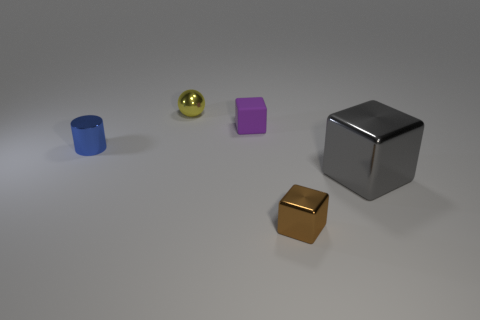Is there any other thing that is the same material as the purple cube?
Make the answer very short. No. There is a gray thing that is the same material as the cylinder; what size is it?
Give a very brief answer. Large. There is a thing behind the purple thing; is there a metal object behind it?
Offer a very short reply. No. What number of other things are the same color as the metallic sphere?
Offer a very short reply. 0. The yellow sphere is what size?
Make the answer very short. Small. Is there a large blue matte cube?
Ensure brevity in your answer.  No. Is the number of blue shiny cylinders that are in front of the cylinder greater than the number of large gray shiny cubes to the left of the brown object?
Keep it short and to the point. No. The thing that is both in front of the yellow shiny sphere and behind the small blue thing is made of what material?
Your response must be concise. Rubber. Is the shape of the yellow object the same as the large gray object?
Your answer should be very brief. No. Is there any other thing that has the same size as the brown block?
Your response must be concise. Yes. 